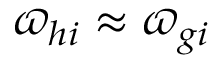<formula> <loc_0><loc_0><loc_500><loc_500>\varpi _ { h i } \approx \varpi _ { g i }</formula> 